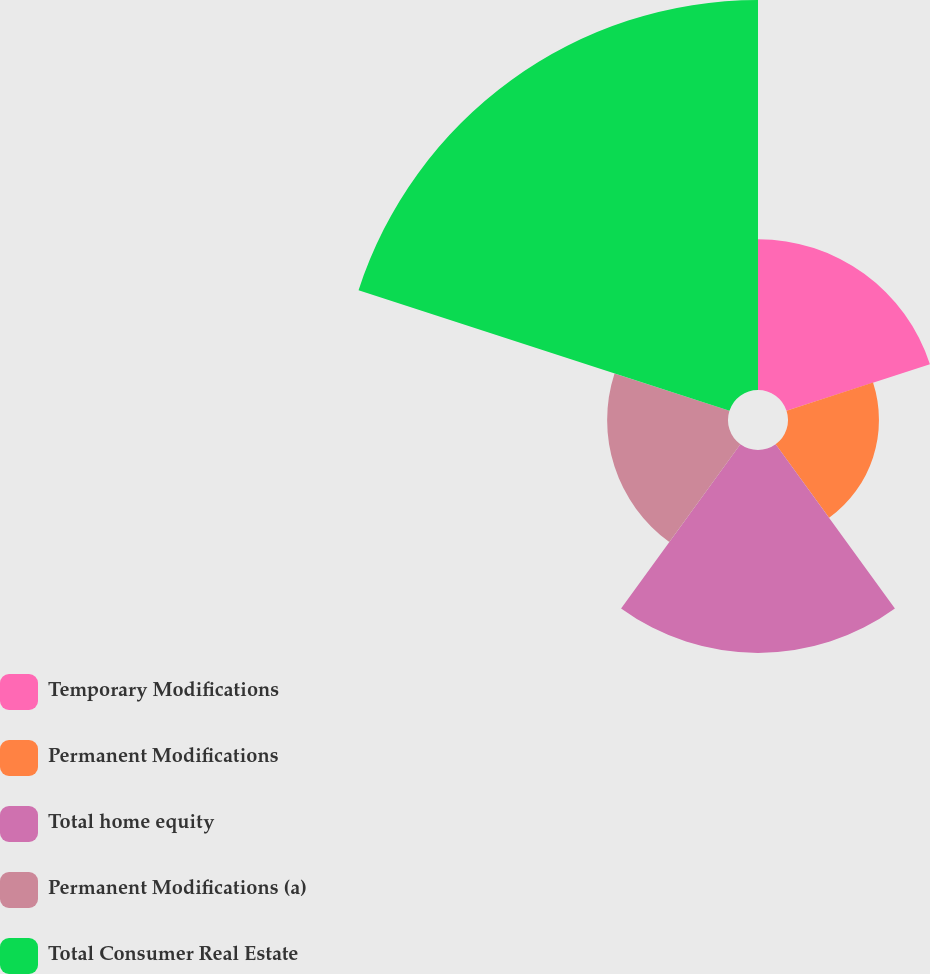Convert chart to OTSL. <chart><loc_0><loc_0><loc_500><loc_500><pie_chart><fcel>Temporary Modifications<fcel>Permanent Modifications<fcel>Total home equity<fcel>Permanent Modifications (a)<fcel>Total Consumer Real Estate<nl><fcel>15.78%<fcel>9.52%<fcel>21.24%<fcel>12.65%<fcel>40.82%<nl></chart> 